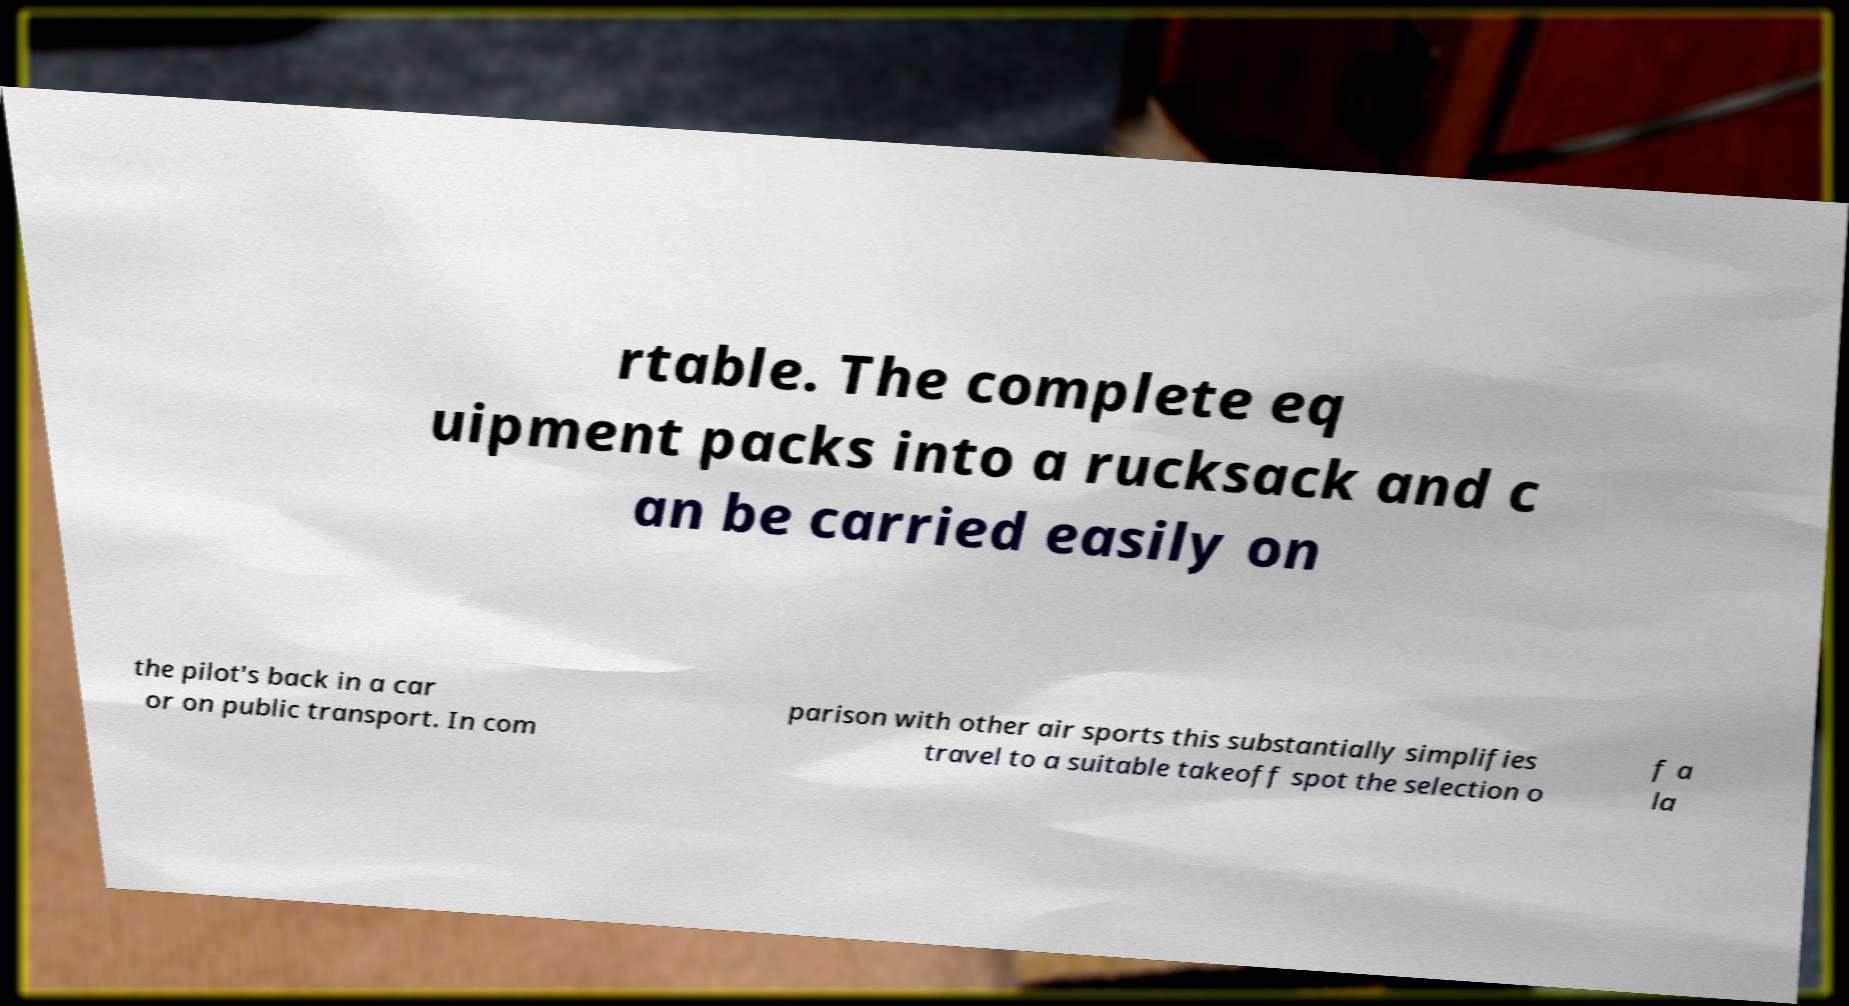For documentation purposes, I need the text within this image transcribed. Could you provide that? rtable. The complete eq uipment packs into a rucksack and c an be carried easily on the pilot's back in a car or on public transport. In com parison with other air sports this substantially simplifies travel to a suitable takeoff spot the selection o f a la 